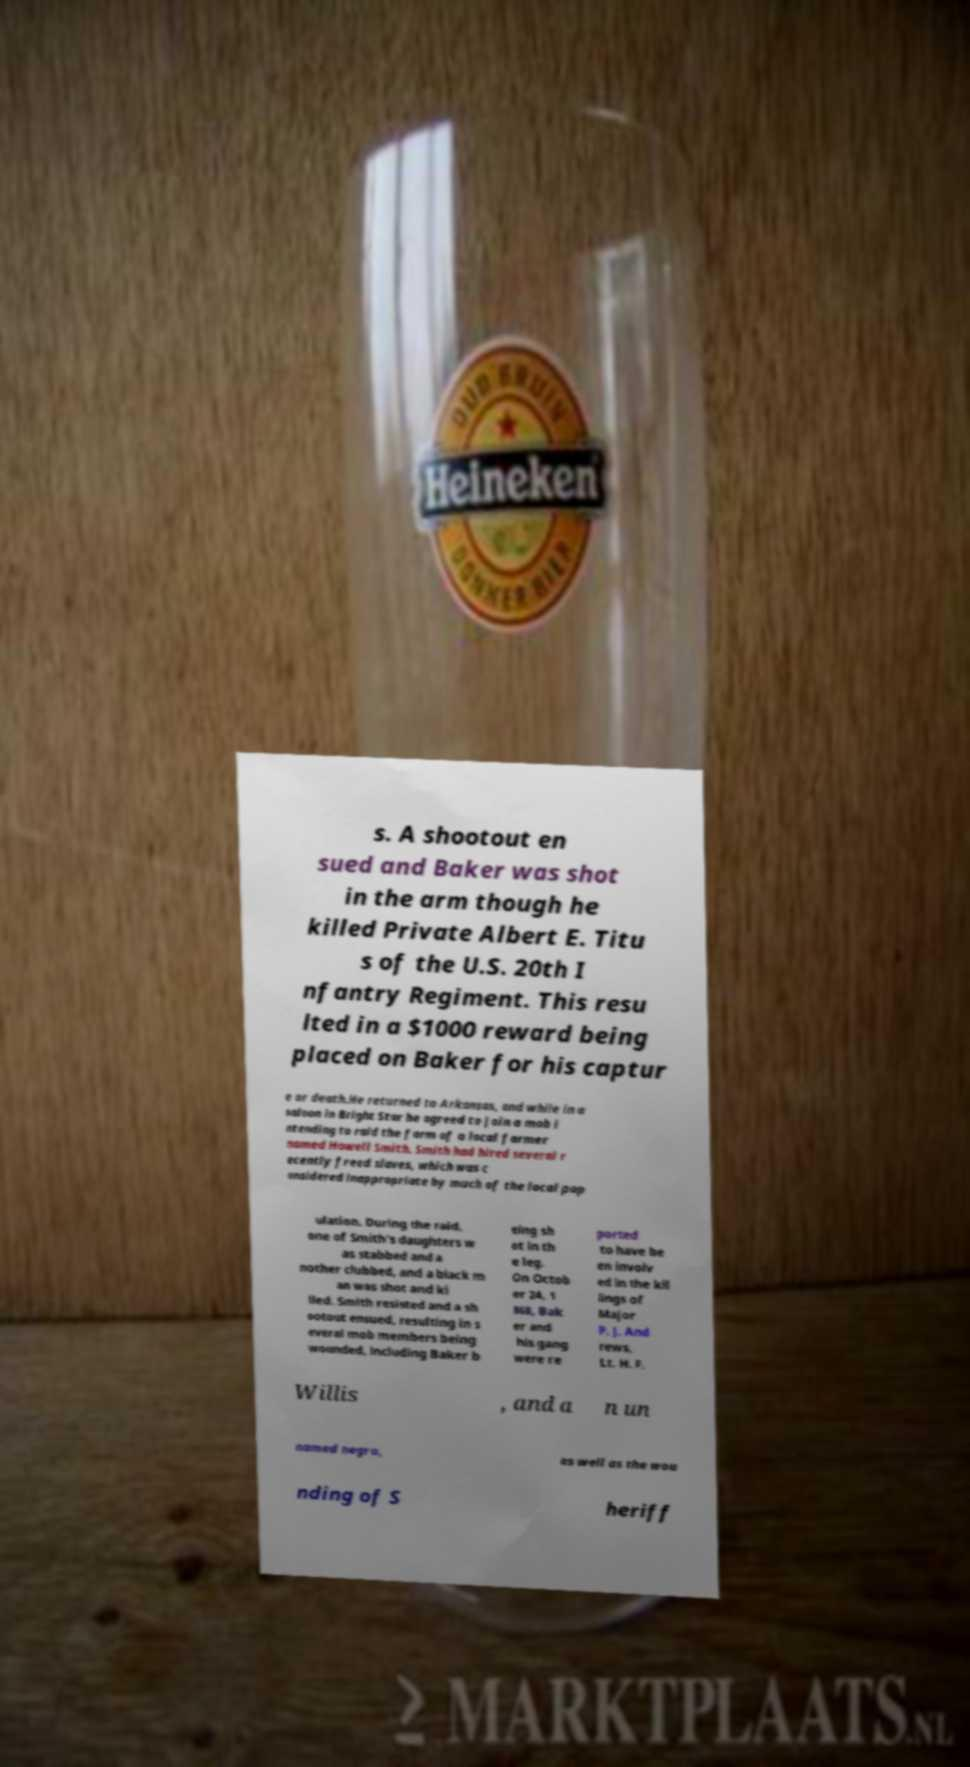There's text embedded in this image that I need extracted. Can you transcribe it verbatim? s. A shootout en sued and Baker was shot in the arm though he killed Private Albert E. Titu s of the U.S. 20th I nfantry Regiment. This resu lted in a $1000 reward being placed on Baker for his captur e or death.He returned to Arkansas, and while in a saloon in Bright Star he agreed to join a mob i ntending to raid the farm of a local farmer named Howell Smith. Smith had hired several r ecently freed slaves, which was c onsidered inappropriate by much of the local pop ulation. During the raid, one of Smith's daughters w as stabbed and a nother clubbed, and a black m an was shot and ki lled. Smith resisted and a sh ootout ensued, resulting in s everal mob members being wounded, including Baker b eing sh ot in th e leg. On Octob er 24, 1 868, Bak er and his gang were re ported to have be en involv ed in the kil lings of Major P. J. And rews, Lt. H. F. Willis , and a n un named negro, as well as the wou nding of S heriff 